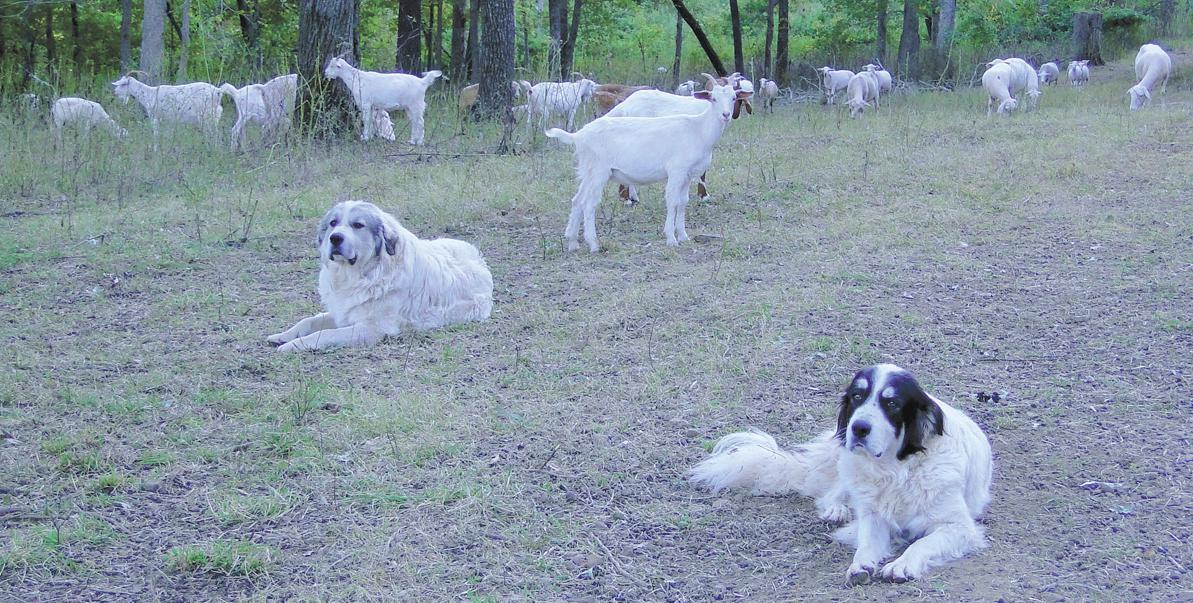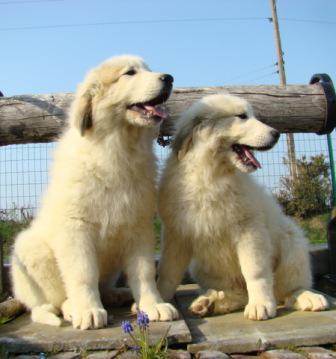The first image is the image on the left, the second image is the image on the right. For the images displayed, is the sentence "There are exactly two dogs in the image on the right." factually correct? Answer yes or no. Yes. The first image is the image on the left, the second image is the image on the right. Assess this claim about the two images: "In one image, one dog is shown with a flock of goats.". Correct or not? Answer yes or no. No. 